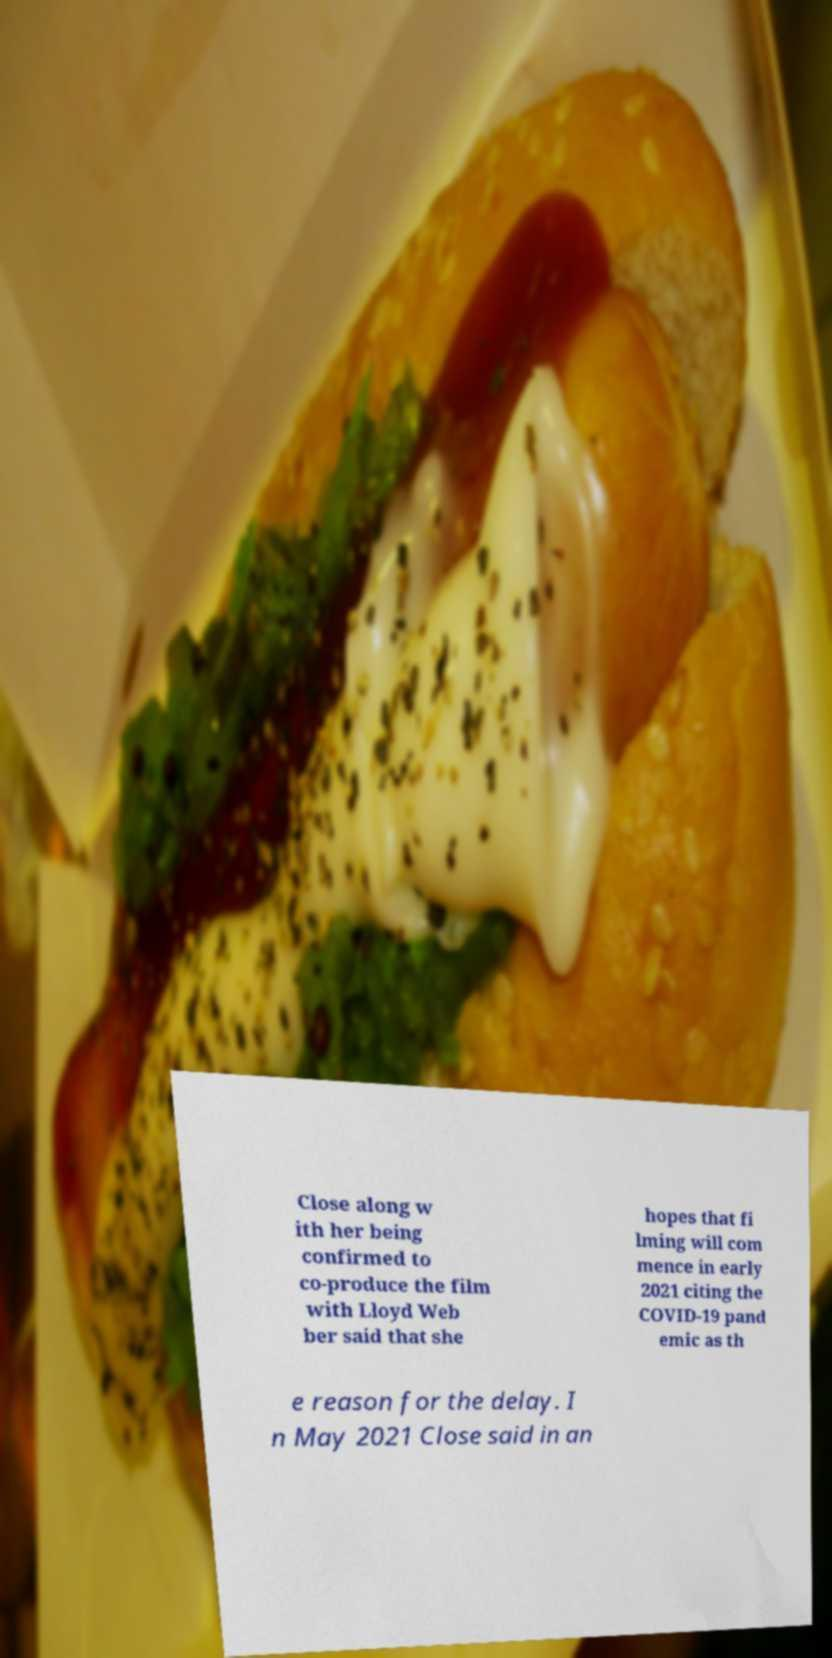Please identify and transcribe the text found in this image. Close along w ith her being confirmed to co-produce the film with Lloyd Web ber said that she hopes that fi lming will com mence in early 2021 citing the COVID-19 pand emic as th e reason for the delay. I n May 2021 Close said in an 